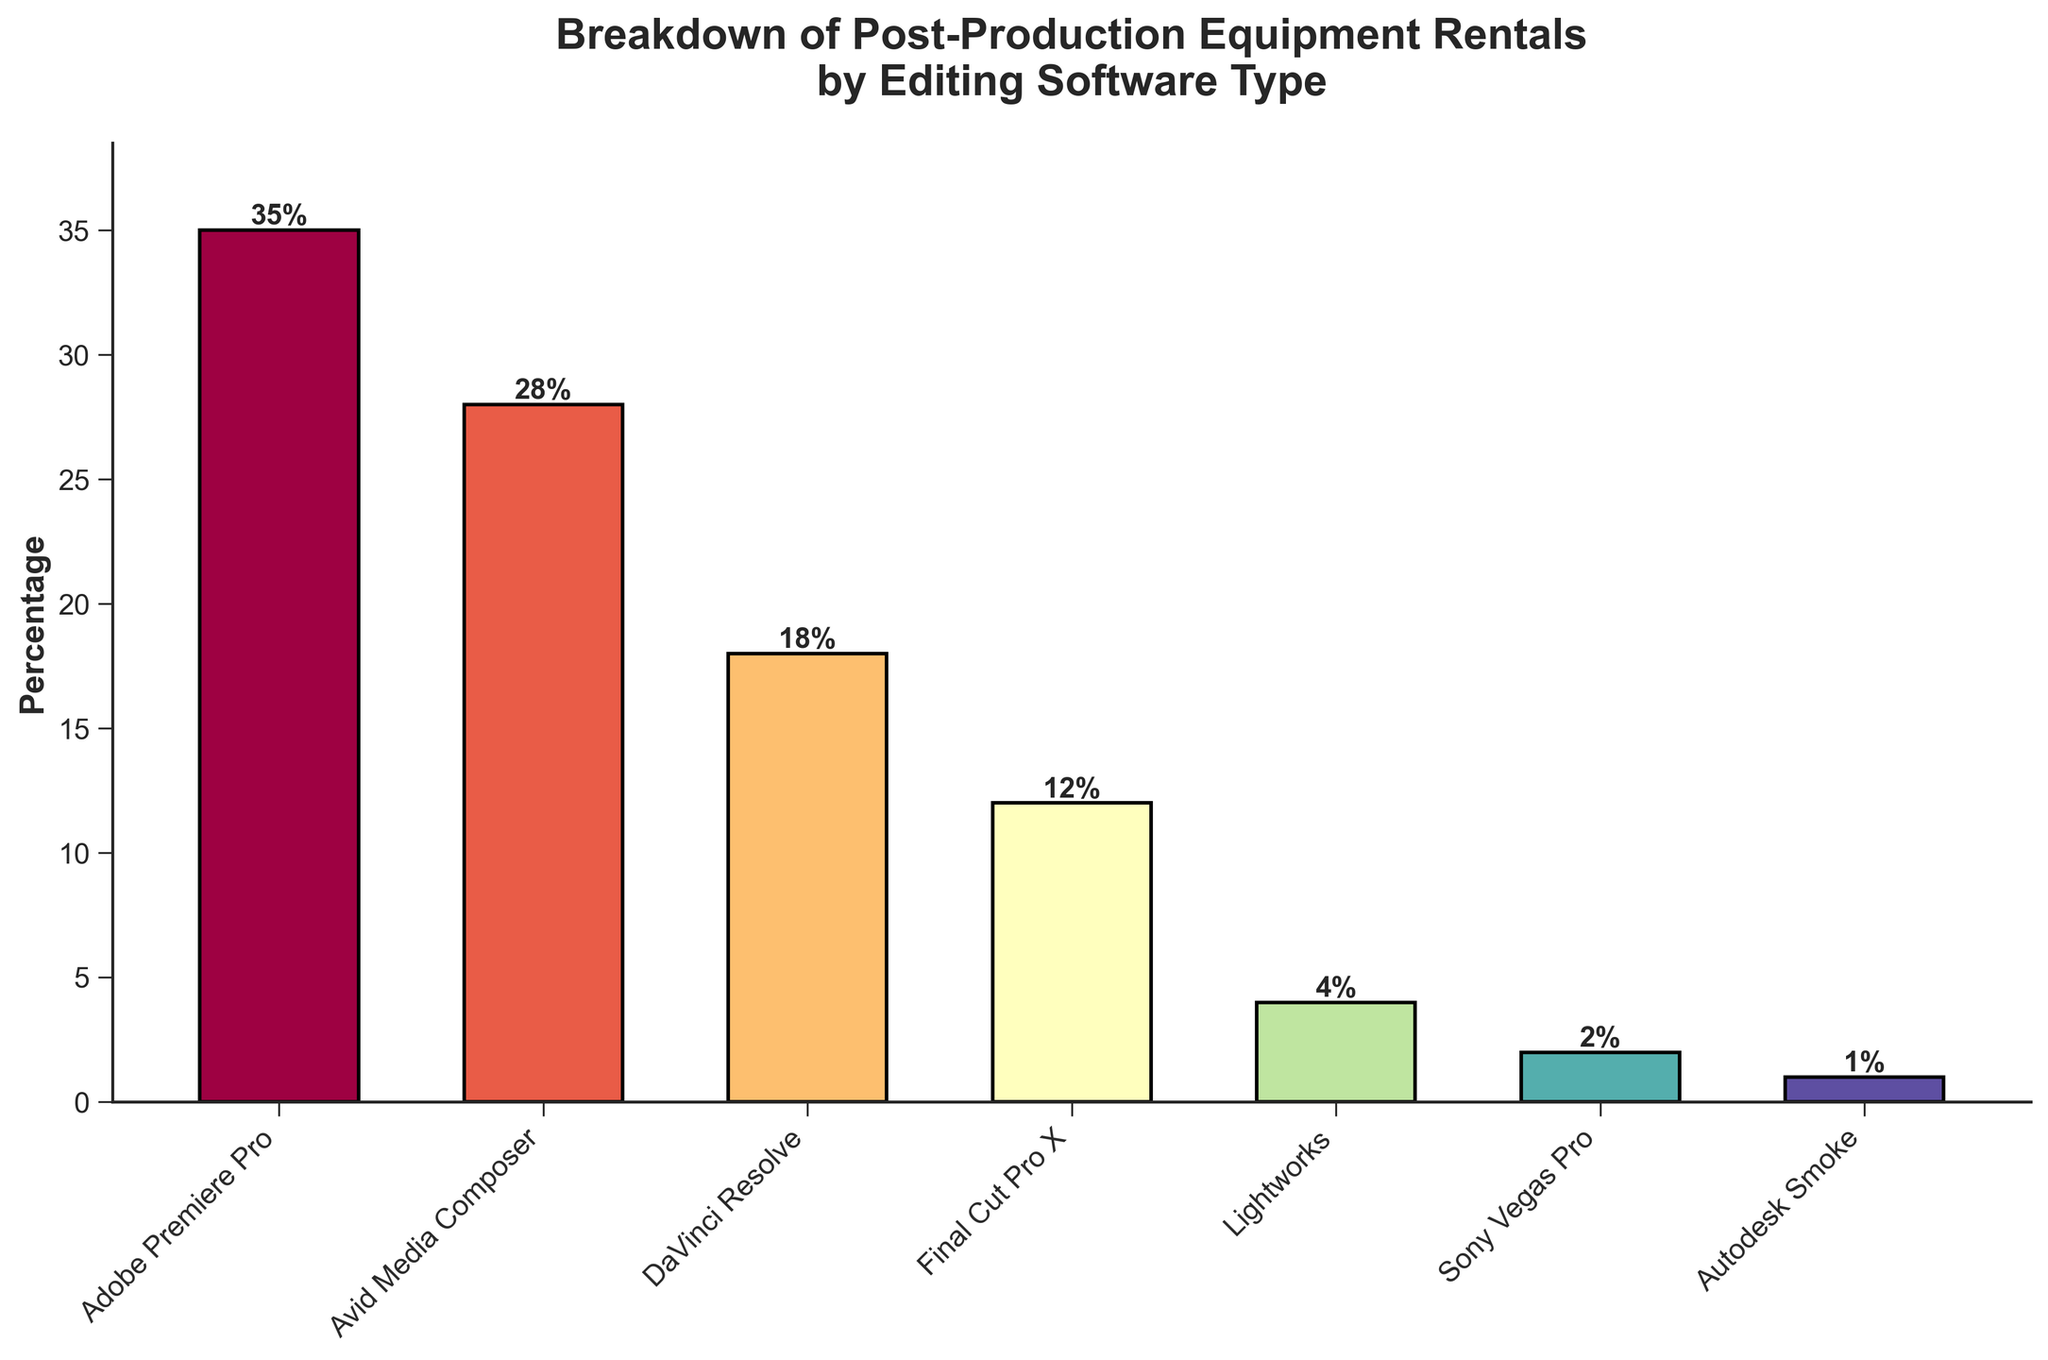Which editing software type has the highest percentage of post-production equipment rentals? By looking at the height of the bars, we can see that Adobe Premiere Pro has the highest percentage.
Answer: Adobe Premiere Pro How much greater is the rental percentage of Adobe Premiere Pro compared to Sony Vegas Pro? The percentage for Adobe Premiere Pro is 35%, and for Sony Vegas Pro, it is 2%. The difference is calculated by 35 - 2 = 33%.
Answer: 33% Which two software types have a combined rental percentage of 30%? Avid Media Composer has 28%, and Lightworks has 4%. Summing them gives 28 + 4 = 32%, which is not correct. Then, DaVinci Resolve has 18%, and Final Cut Pro X has 12%, summing them gives 18 + 12 = 30%.
Answer: DaVinci Resolve and Final Cut Pro X Are there more rentals of DaVinci Resolve than Final Cut Pro X? DaVinci Resolve has a percentage of 18%, and Final Cut Pro X has 12%. Yes, 18 > 12.
Answer: Yes Which software type has the smallest percentage of post-production equipment rentals? By observing the bar heights, Autodesk Smoke has the smallest percentage, which is 1%.
Answer: Autodesk Smoke What is the total combined percentage for Avid Media Composer, DaVinci Resolve, and Lightworks? Avid Media Composer has 28%, DaVinci Resolve has 18%, and Lightworks has 4%. Adding these gives us 28 + 18 + 4 = 50%.
Answer: 50% How does the rental percentage of Final Cut Pro X compare to that of Lightworks visually? The bar for Final Cut Pro X is higher than that of Lightworks, indicating that Final Cut Pro X has a larger percentage. Specifically, Final Cut Pro X has 12%, and Lightworks has 4%.
Answer: Higher Is the percentage difference between the software with the highest and lowest rentals greater than 30%? The highest is Adobe Premiere Pro at 35%, and the lowest is Autodesk Smoke at 1%. The difference is 35 - 1 = 34%, which is greater than 30%.
Answer: Yes Which software types have rental percentages under 10%? Lightworks has 4%, Sony Vegas Pro has 2%, and Autodesk Smoke has 1%. Therefore, these are all under 10%.
Answer: Lightworks, Sony Vegas Pro, Autodesk Smoke What is the average rental percentage of Adobe Premiere Pro, Avid Media Composer, and DaVinci Resolve? Adding these percentages gives 35 + 28 + 18 = 81. There are three software types, so the average is 81/3 = 27%.
Answer: 27% 